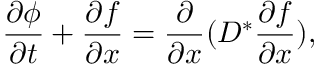<formula> <loc_0><loc_0><loc_500><loc_500>\frac { \partial \phi } { \partial t } + \frac { \partial f } { \partial x } = \frac { \partial } { \partial x } ( D ^ { \ast } \frac { \partial f } { \partial x } ) ,</formula> 